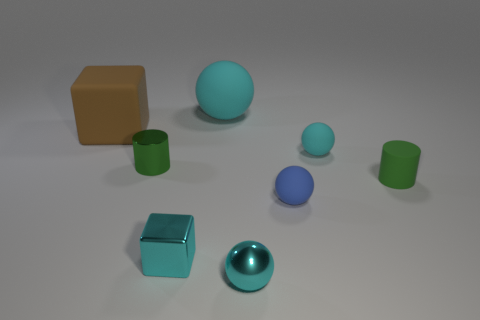Subtract all green cylinders. How many cyan spheres are left? 3 Subtract 1 balls. How many balls are left? 3 Add 1 big gray metal spheres. How many objects exist? 9 Subtract all red balls. Subtract all gray cylinders. How many balls are left? 4 Subtract all cylinders. How many objects are left? 6 Subtract all big gray metal objects. Subtract all large brown matte cubes. How many objects are left? 7 Add 4 small matte objects. How many small matte objects are left? 7 Add 6 big brown things. How many big brown things exist? 7 Subtract 0 yellow cylinders. How many objects are left? 8 